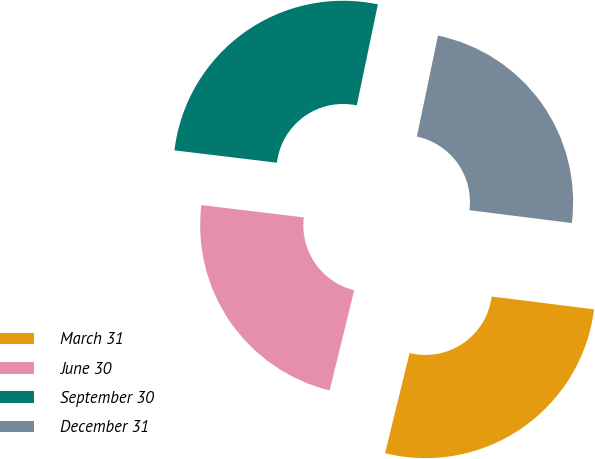<chart> <loc_0><loc_0><loc_500><loc_500><pie_chart><fcel>March 31<fcel>June 30<fcel>September 30<fcel>December 31<nl><fcel>26.84%<fcel>23.09%<fcel>26.37%<fcel>23.71%<nl></chart> 